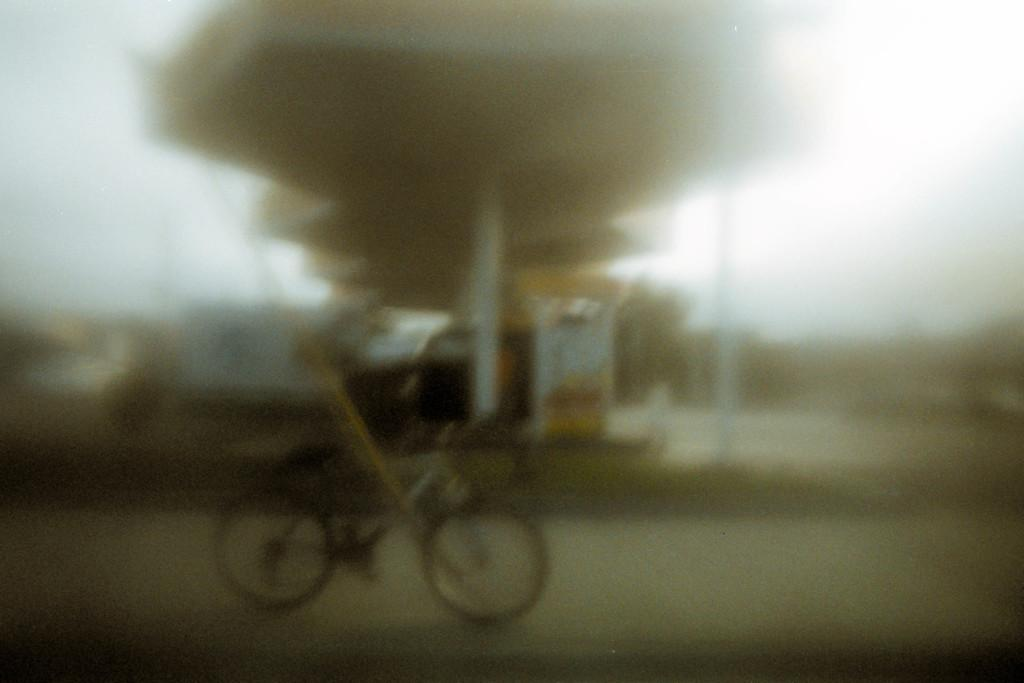What is the main subject of the image? The main subject of the image is a bicycle. Where is the bicycle located in the image? The bicycle is on the road in the image. What can be seen in the background of the image? Trees and the sky are visible in the image. Are there any other vehicles or objects on the road in the image? Yes, there is a vehicle on the road in the image. How does the bicycle react to the quicksand on the road in the image? There is no quicksand present in the image, so the bicycle does not react to it. 